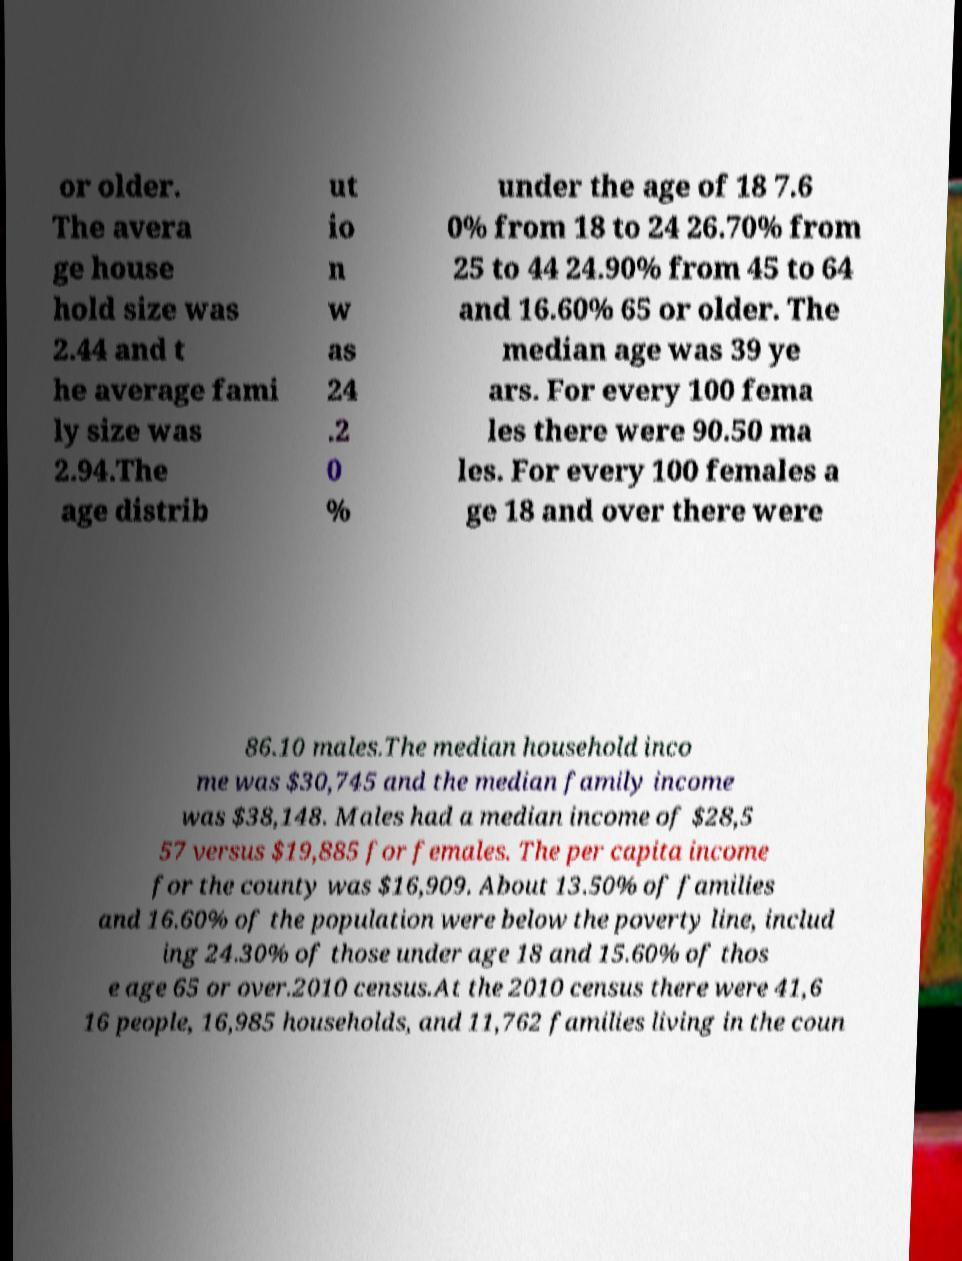Please read and relay the text visible in this image. What does it say? or older. The avera ge house hold size was 2.44 and t he average fami ly size was 2.94.The age distrib ut io n w as 24 .2 0 % under the age of 18 7.6 0% from 18 to 24 26.70% from 25 to 44 24.90% from 45 to 64 and 16.60% 65 or older. The median age was 39 ye ars. For every 100 fema les there were 90.50 ma les. For every 100 females a ge 18 and over there were 86.10 males.The median household inco me was $30,745 and the median family income was $38,148. Males had a median income of $28,5 57 versus $19,885 for females. The per capita income for the county was $16,909. About 13.50% of families and 16.60% of the population were below the poverty line, includ ing 24.30% of those under age 18 and 15.60% of thos e age 65 or over.2010 census.At the 2010 census there were 41,6 16 people, 16,985 households, and 11,762 families living in the coun 